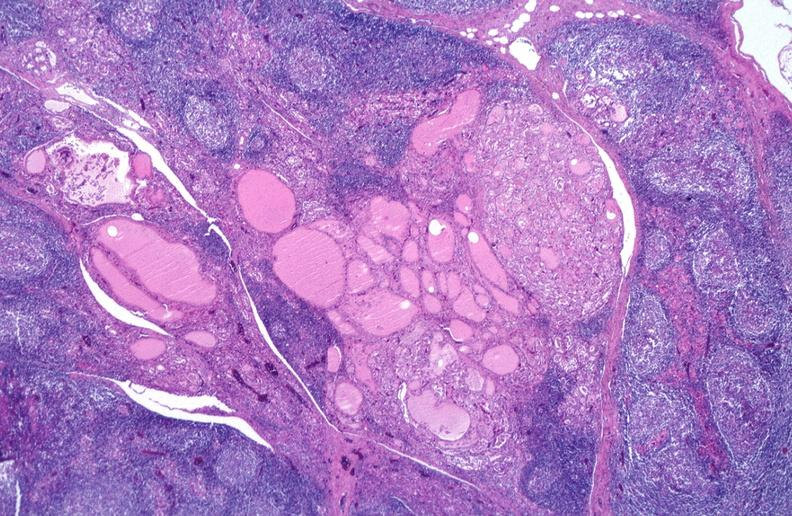what is present?
Answer the question using a single word or phrase. Endocrine 